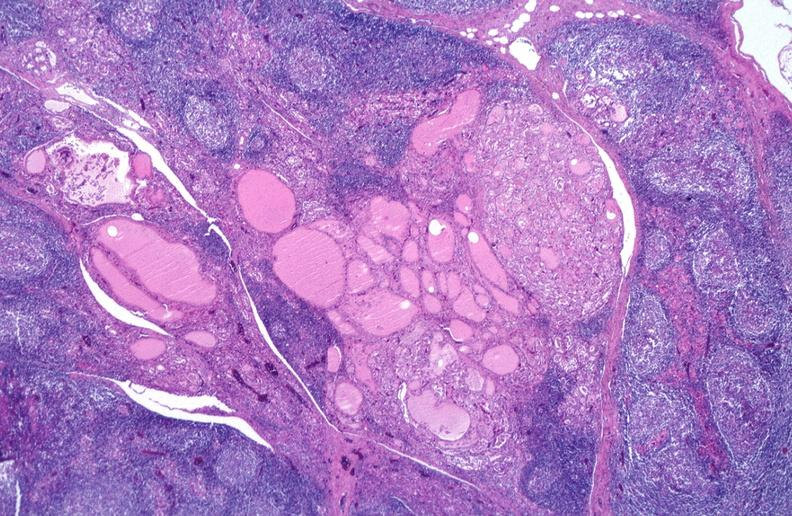what is present?
Answer the question using a single word or phrase. Endocrine 